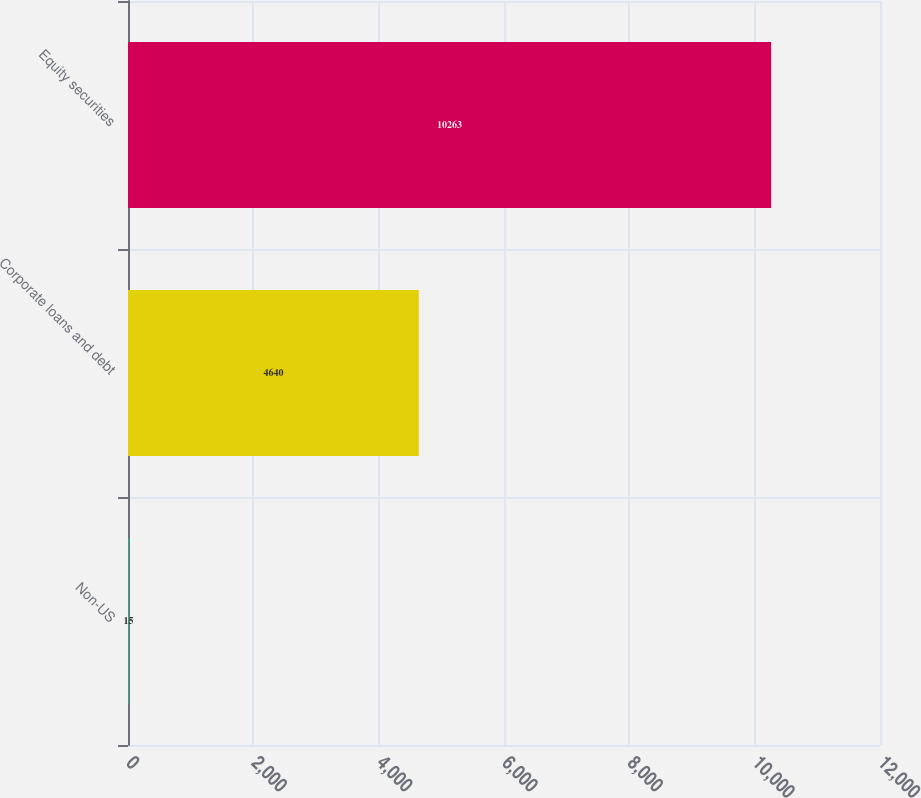Convert chart to OTSL. <chart><loc_0><loc_0><loc_500><loc_500><bar_chart><fcel>Non-US<fcel>Corporate loans and debt<fcel>Equity securities<nl><fcel>15<fcel>4640<fcel>10263<nl></chart> 